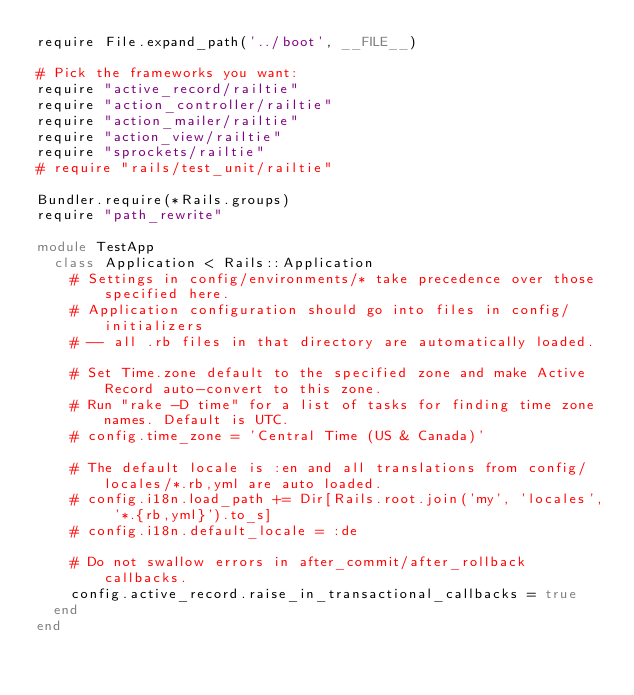<code> <loc_0><loc_0><loc_500><loc_500><_Ruby_>require File.expand_path('../boot', __FILE__)

# Pick the frameworks you want:
require "active_record/railtie"
require "action_controller/railtie"
require "action_mailer/railtie"
require "action_view/railtie"
require "sprockets/railtie"
# require "rails/test_unit/railtie"

Bundler.require(*Rails.groups)
require "path_rewrite"

module TestApp
  class Application < Rails::Application
    # Settings in config/environments/* take precedence over those specified here.
    # Application configuration should go into files in config/initializers
    # -- all .rb files in that directory are automatically loaded.

    # Set Time.zone default to the specified zone and make Active Record auto-convert to this zone.
    # Run "rake -D time" for a list of tasks for finding time zone names. Default is UTC.
    # config.time_zone = 'Central Time (US & Canada)'

    # The default locale is :en and all translations from config/locales/*.rb,yml are auto loaded.
    # config.i18n.load_path += Dir[Rails.root.join('my', 'locales', '*.{rb,yml}').to_s]
    # config.i18n.default_locale = :de

    # Do not swallow errors in after_commit/after_rollback callbacks.
    config.active_record.raise_in_transactional_callbacks = true
  end
end

</code> 